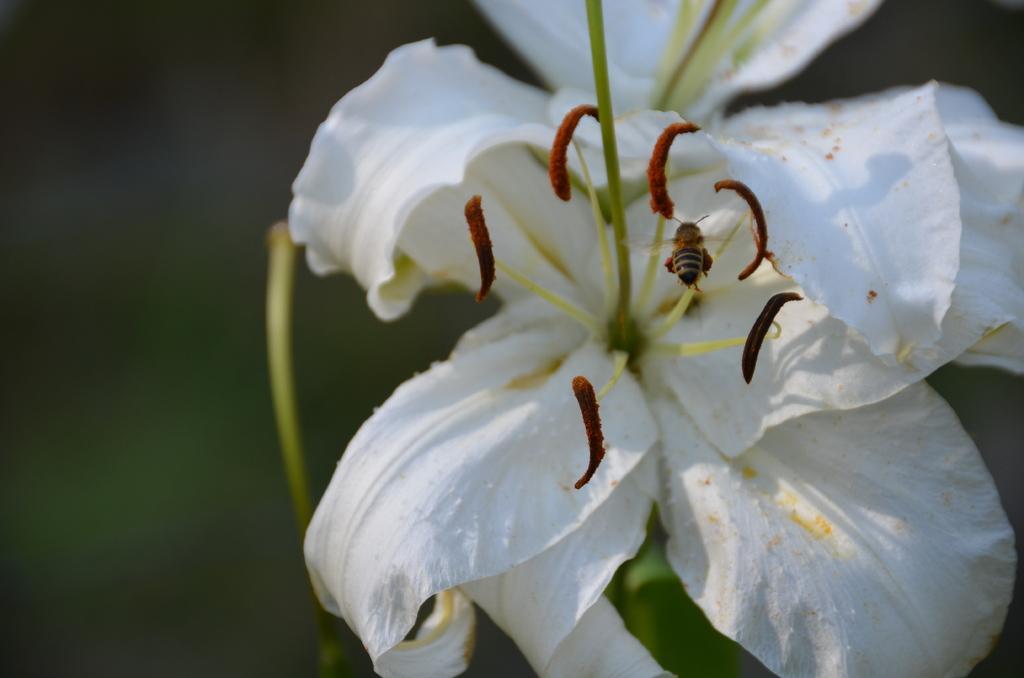Describe this image in one or two sentences. On the right side, there are two white color flowers. On one of these flowers, there is an insect. And the background is blurred. 